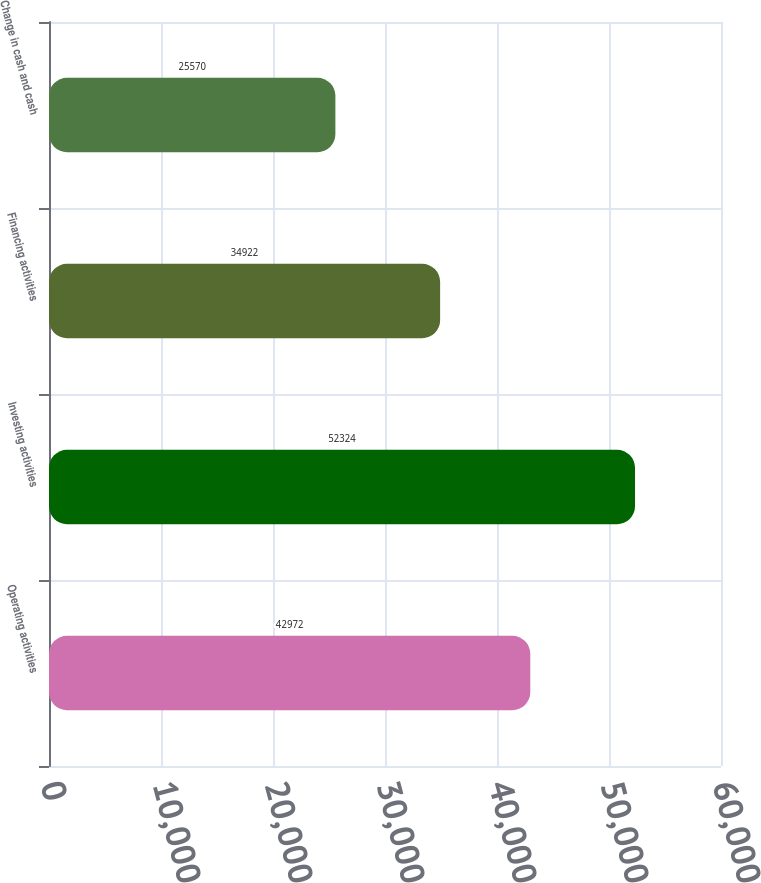Convert chart to OTSL. <chart><loc_0><loc_0><loc_500><loc_500><bar_chart><fcel>Operating activities<fcel>Investing activities<fcel>Financing activities<fcel>Change in cash and cash<nl><fcel>42972<fcel>52324<fcel>34922<fcel>25570<nl></chart> 